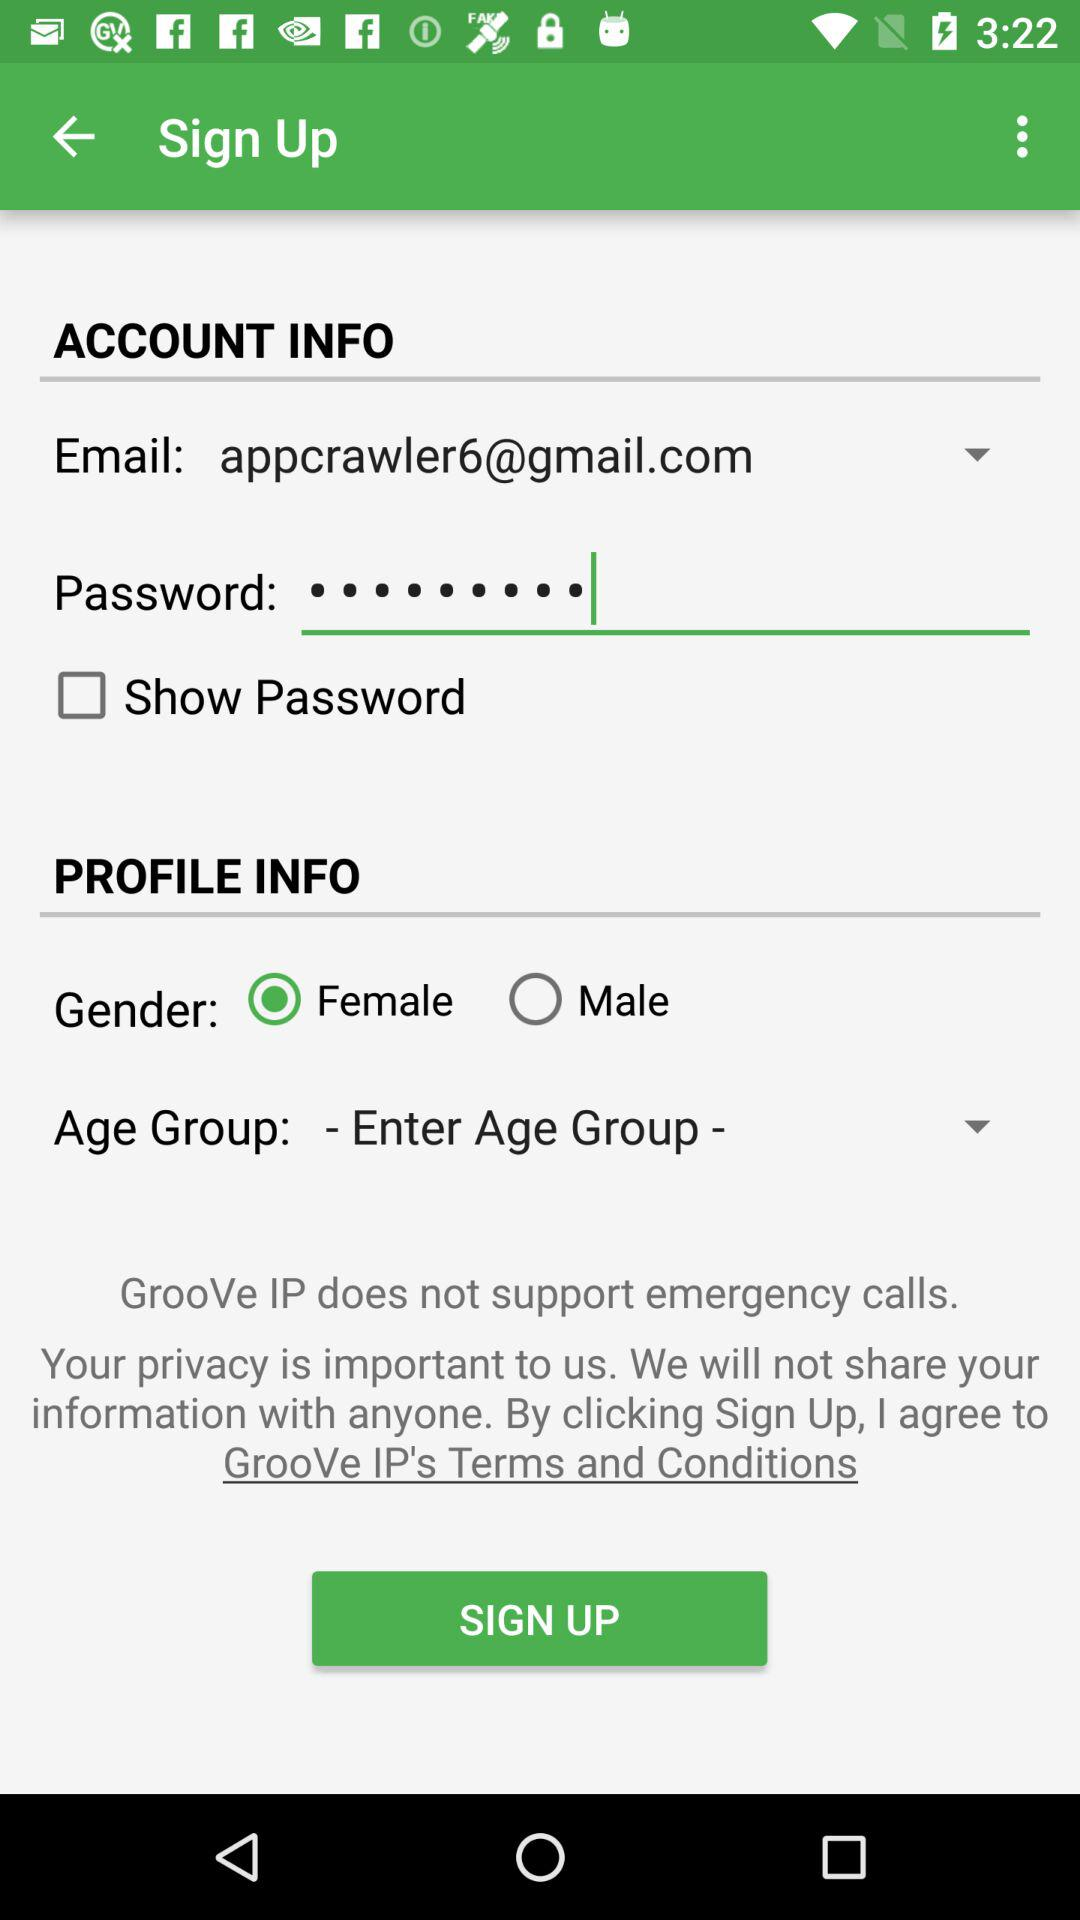What is the status of show password? The status is "off". 